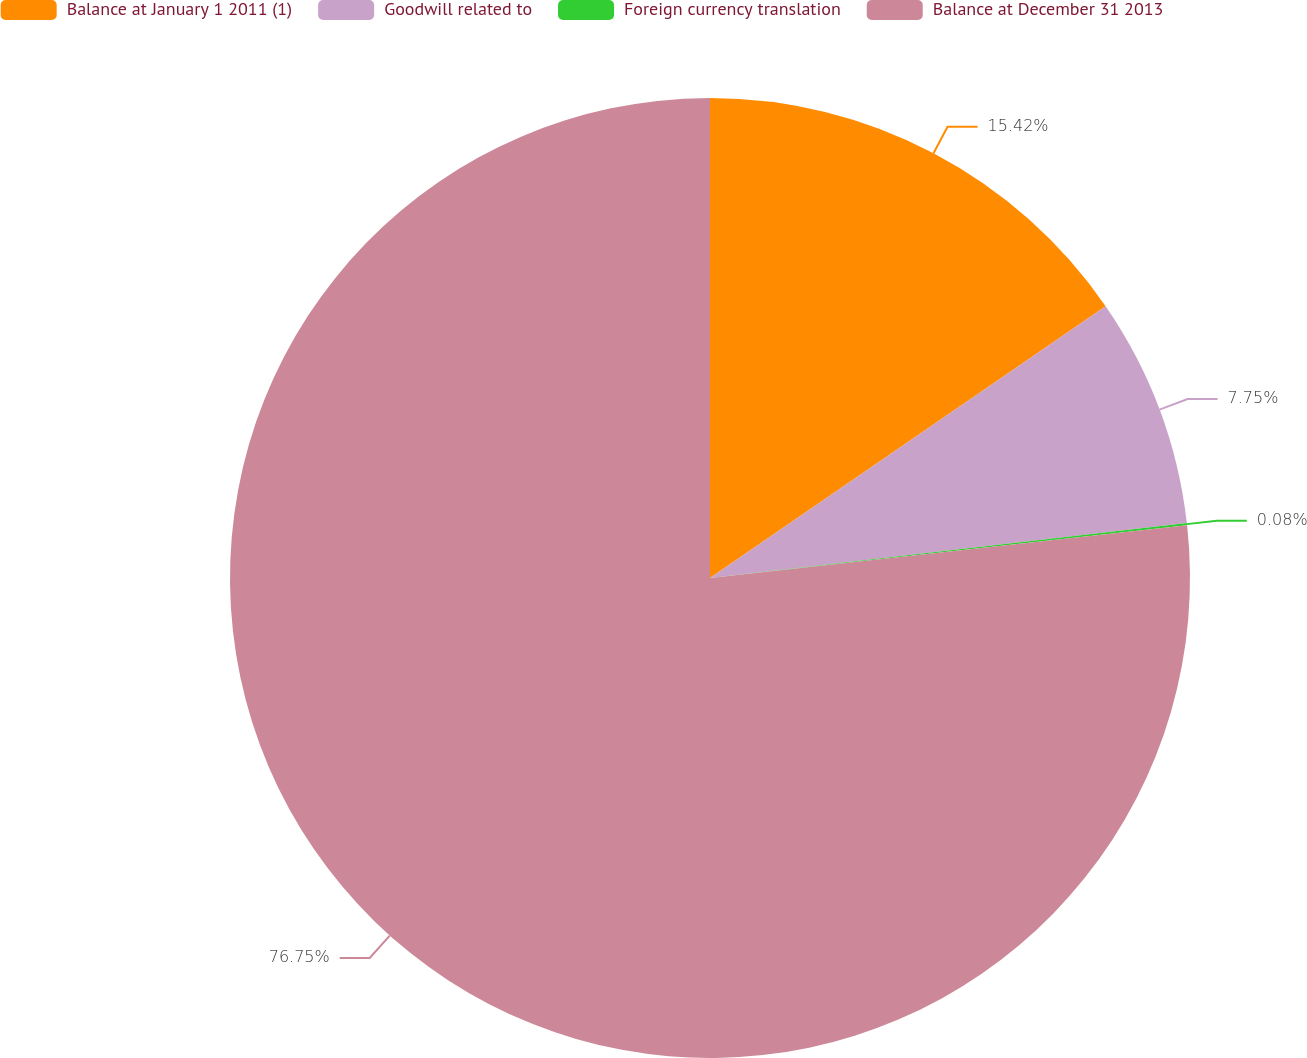Convert chart. <chart><loc_0><loc_0><loc_500><loc_500><pie_chart><fcel>Balance at January 1 2011 (1)<fcel>Goodwill related to<fcel>Foreign currency translation<fcel>Balance at December 31 2013<nl><fcel>15.42%<fcel>7.75%<fcel>0.08%<fcel>76.75%<nl></chart> 